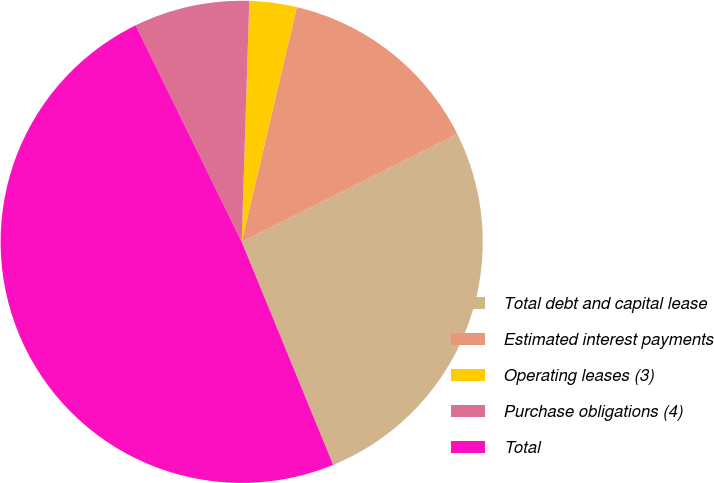Convert chart. <chart><loc_0><loc_0><loc_500><loc_500><pie_chart><fcel>Total debt and capital lease<fcel>Estimated interest payments<fcel>Operating leases (3)<fcel>Purchase obligations (4)<fcel>Total<nl><fcel>26.2%<fcel>13.93%<fcel>3.17%<fcel>7.75%<fcel>48.95%<nl></chart> 